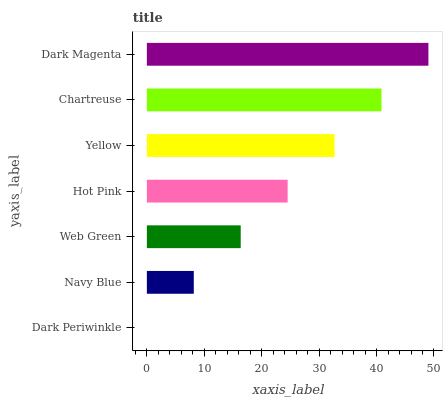Is Dark Periwinkle the minimum?
Answer yes or no. Yes. Is Dark Magenta the maximum?
Answer yes or no. Yes. Is Navy Blue the minimum?
Answer yes or no. No. Is Navy Blue the maximum?
Answer yes or no. No. Is Navy Blue greater than Dark Periwinkle?
Answer yes or no. Yes. Is Dark Periwinkle less than Navy Blue?
Answer yes or no. Yes. Is Dark Periwinkle greater than Navy Blue?
Answer yes or no. No. Is Navy Blue less than Dark Periwinkle?
Answer yes or no. No. Is Hot Pink the high median?
Answer yes or no. Yes. Is Hot Pink the low median?
Answer yes or no. Yes. Is Dark Magenta the high median?
Answer yes or no. No. Is Chartreuse the low median?
Answer yes or no. No. 